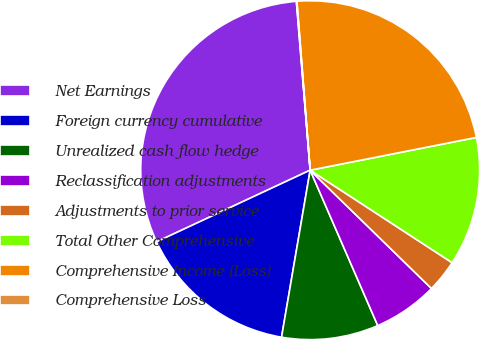Convert chart to OTSL. <chart><loc_0><loc_0><loc_500><loc_500><pie_chart><fcel>Net Earnings<fcel>Foreign currency cumulative<fcel>Unrealized cash flow hedge<fcel>Reclassification adjustments<fcel>Adjustments to prior service<fcel>Total Other Comprehensive<fcel>Comprehensive Income (Loss)<fcel>Comprehensive Loss<nl><fcel>30.65%<fcel>15.35%<fcel>9.23%<fcel>6.17%<fcel>3.11%<fcel>12.29%<fcel>23.15%<fcel>0.05%<nl></chart> 